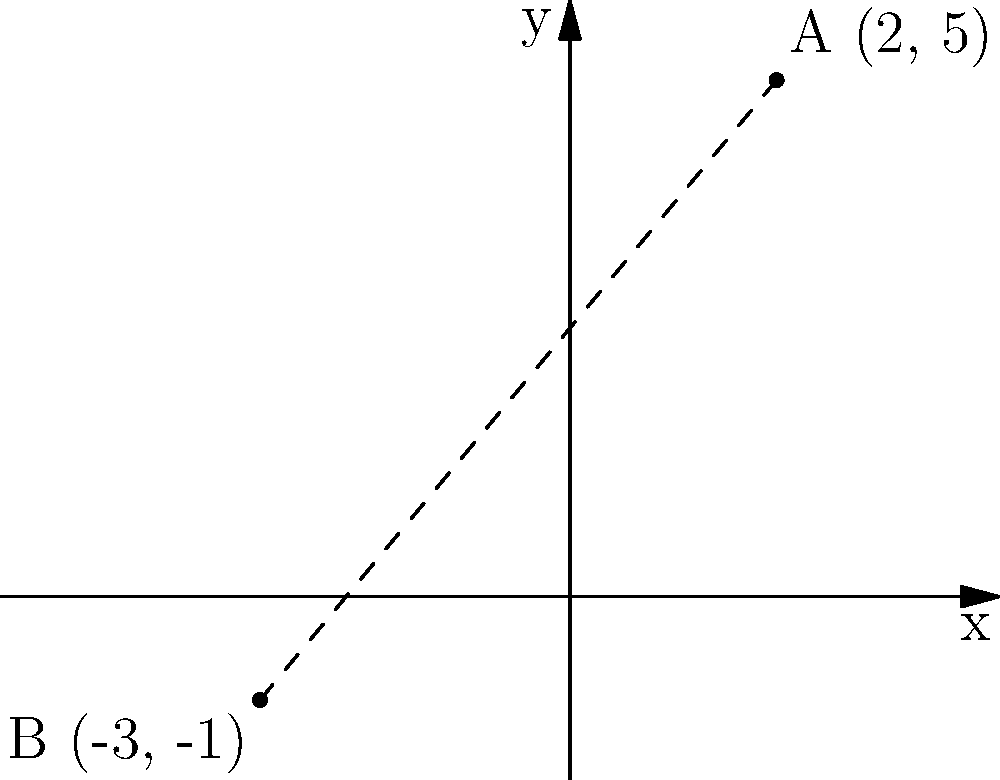Two hidden locations, A and B, are marked on a coordinate plane. Location A is at (2, 5) and location B is at (-3, -1). Calculate the distance between these two locations using the distance formula. To find the distance between two points on a coordinate plane, we use the distance formula:

$$ d = \sqrt{(x_2 - x_1)^2 + (y_2 - y_1)^2} $$

Where $(x_1, y_1)$ are the coordinates of the first point and $(x_2, y_2)$ are the coordinates of the second point.

Let's plug in our values:
* Point A: $(x_1, y_1) = (2, 5)$
* Point B: $(x_2, y_2) = (-3, -1)$

Now, let's calculate:

1) $x_2 - x_1 = -3 - 2 = -5$
2) $y_2 - y_1 = -1 - 5 = -6$

Plugging these into our formula:

$$ d = \sqrt{(-5)^2 + (-6)^2} $$

3) Simplify inside the parentheses:
$$ d = \sqrt{25 + 36} $$

4) Add under the square root:
$$ d = \sqrt{61} $$

5) This cannot be simplified further, so this is our final answer.
Answer: $\sqrt{61}$ units 